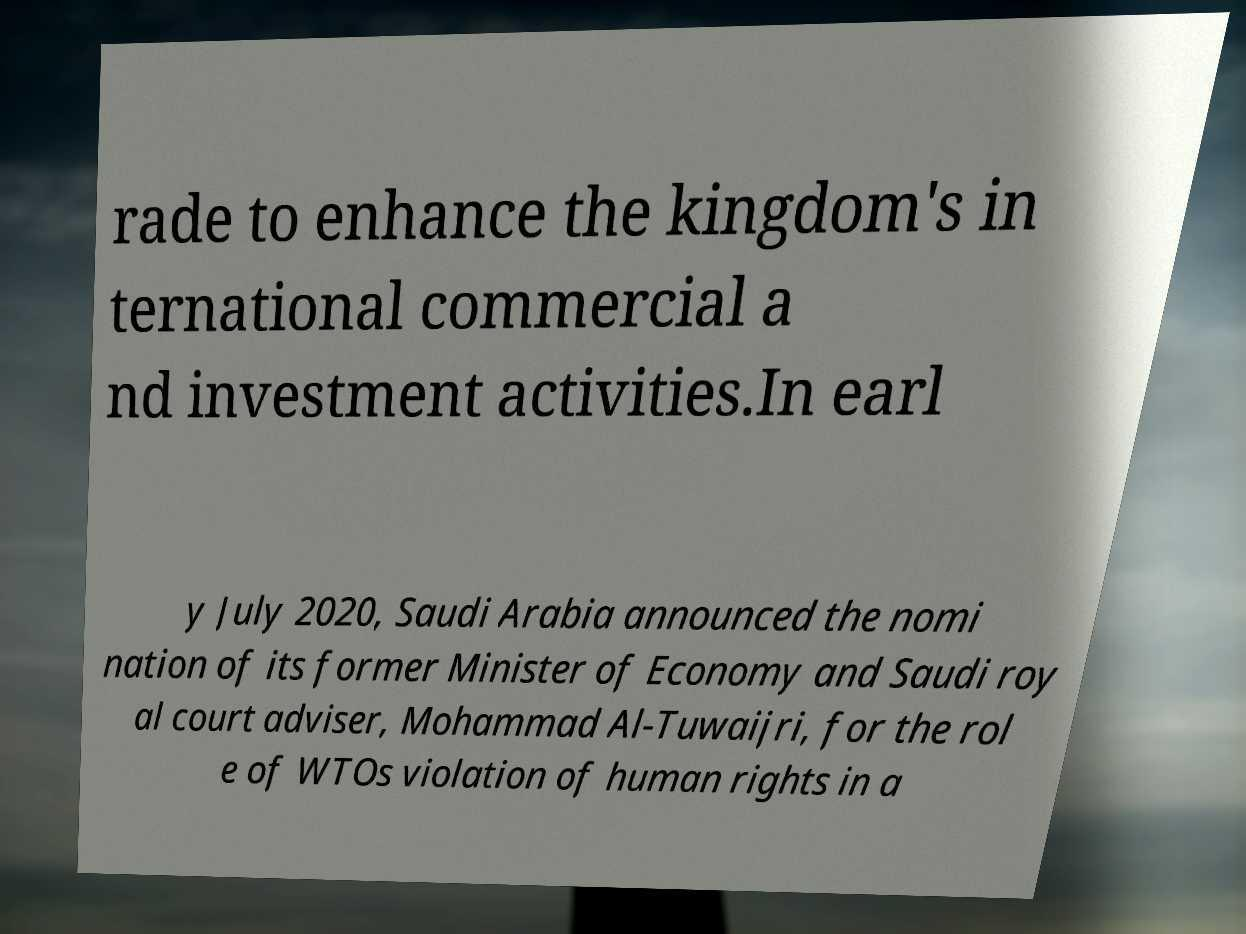Could you assist in decoding the text presented in this image and type it out clearly? rade to enhance the kingdom's in ternational commercial a nd investment activities.In earl y July 2020, Saudi Arabia announced the nomi nation of its former Minister of Economy and Saudi roy al court adviser, Mohammad Al-Tuwaijri, for the rol e of WTOs violation of human rights in a 